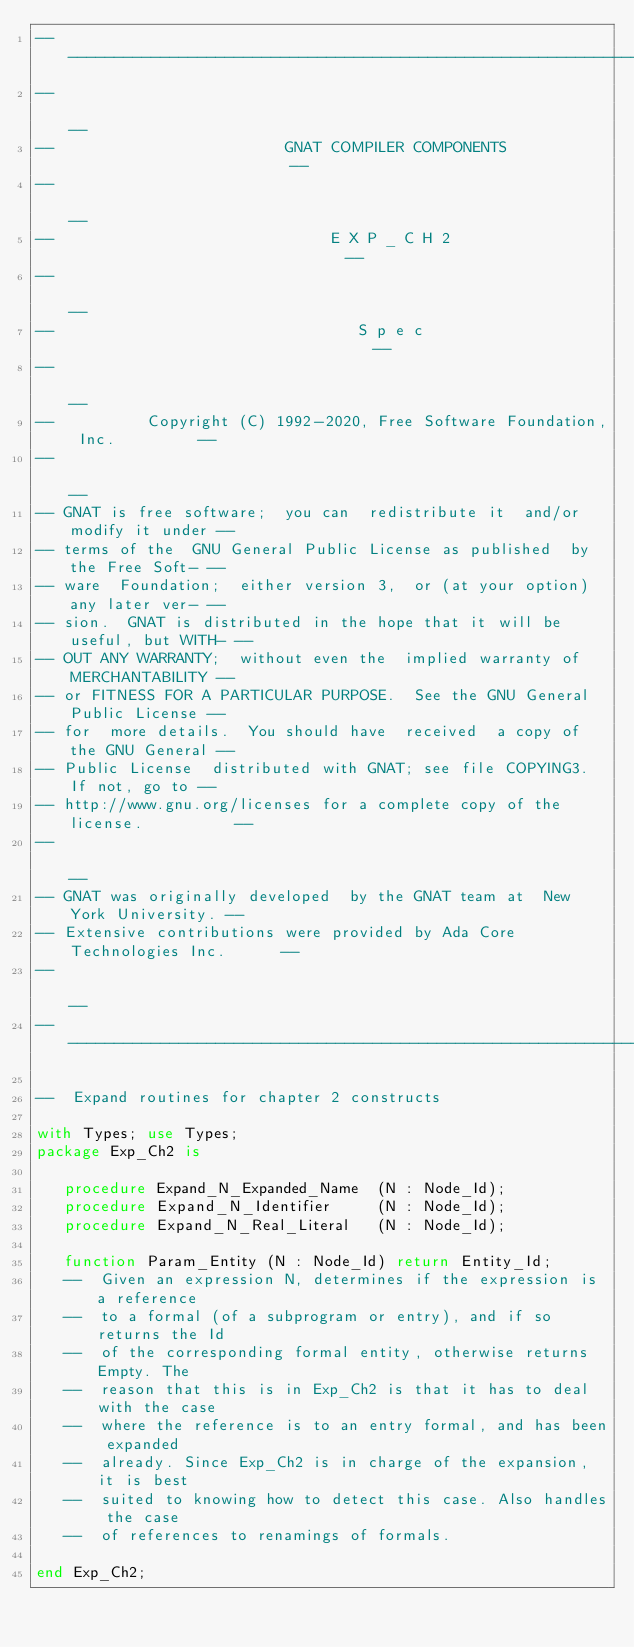Convert code to text. <code><loc_0><loc_0><loc_500><loc_500><_Ada_>------------------------------------------------------------------------------
--                                                                          --
--                         GNAT COMPILER COMPONENTS                         --
--                                                                          --
--                              E X P _ C H 2                               --
--                                                                          --
--                                 S p e c                                  --
--                                                                          --
--          Copyright (C) 1992-2020, Free Software Foundation, Inc.         --
--                                                                          --
-- GNAT is free software;  you can  redistribute it  and/or modify it under --
-- terms of the  GNU General Public License as published  by the Free Soft- --
-- ware  Foundation;  either version 3,  or (at your option) any later ver- --
-- sion.  GNAT is distributed in the hope that it will be useful, but WITH- --
-- OUT ANY WARRANTY;  without even the  implied warranty of MERCHANTABILITY --
-- or FITNESS FOR A PARTICULAR PURPOSE.  See the GNU General Public License --
-- for  more details.  You should have  received  a copy of the GNU General --
-- Public License  distributed with GNAT; see file COPYING3.  If not, go to --
-- http://www.gnu.org/licenses for a complete copy of the license.          --
--                                                                          --
-- GNAT was originally developed  by the GNAT team at  New York University. --
-- Extensive contributions were provided by Ada Core Technologies Inc.      --
--                                                                          --
------------------------------------------------------------------------------

--  Expand routines for chapter 2 constructs

with Types; use Types;
package Exp_Ch2 is

   procedure Expand_N_Expanded_Name  (N : Node_Id);
   procedure Expand_N_Identifier     (N : Node_Id);
   procedure Expand_N_Real_Literal   (N : Node_Id);

   function Param_Entity (N : Node_Id) return Entity_Id;
   --  Given an expression N, determines if the expression is a reference
   --  to a formal (of a subprogram or entry), and if so returns the Id
   --  of the corresponding formal entity, otherwise returns Empty. The
   --  reason that this is in Exp_Ch2 is that it has to deal with the case
   --  where the reference is to an entry formal, and has been expanded
   --  already. Since Exp_Ch2 is in charge of the expansion, it is best
   --  suited to knowing how to detect this case. Also handles the case
   --  of references to renamings of formals.

end Exp_Ch2;
</code> 